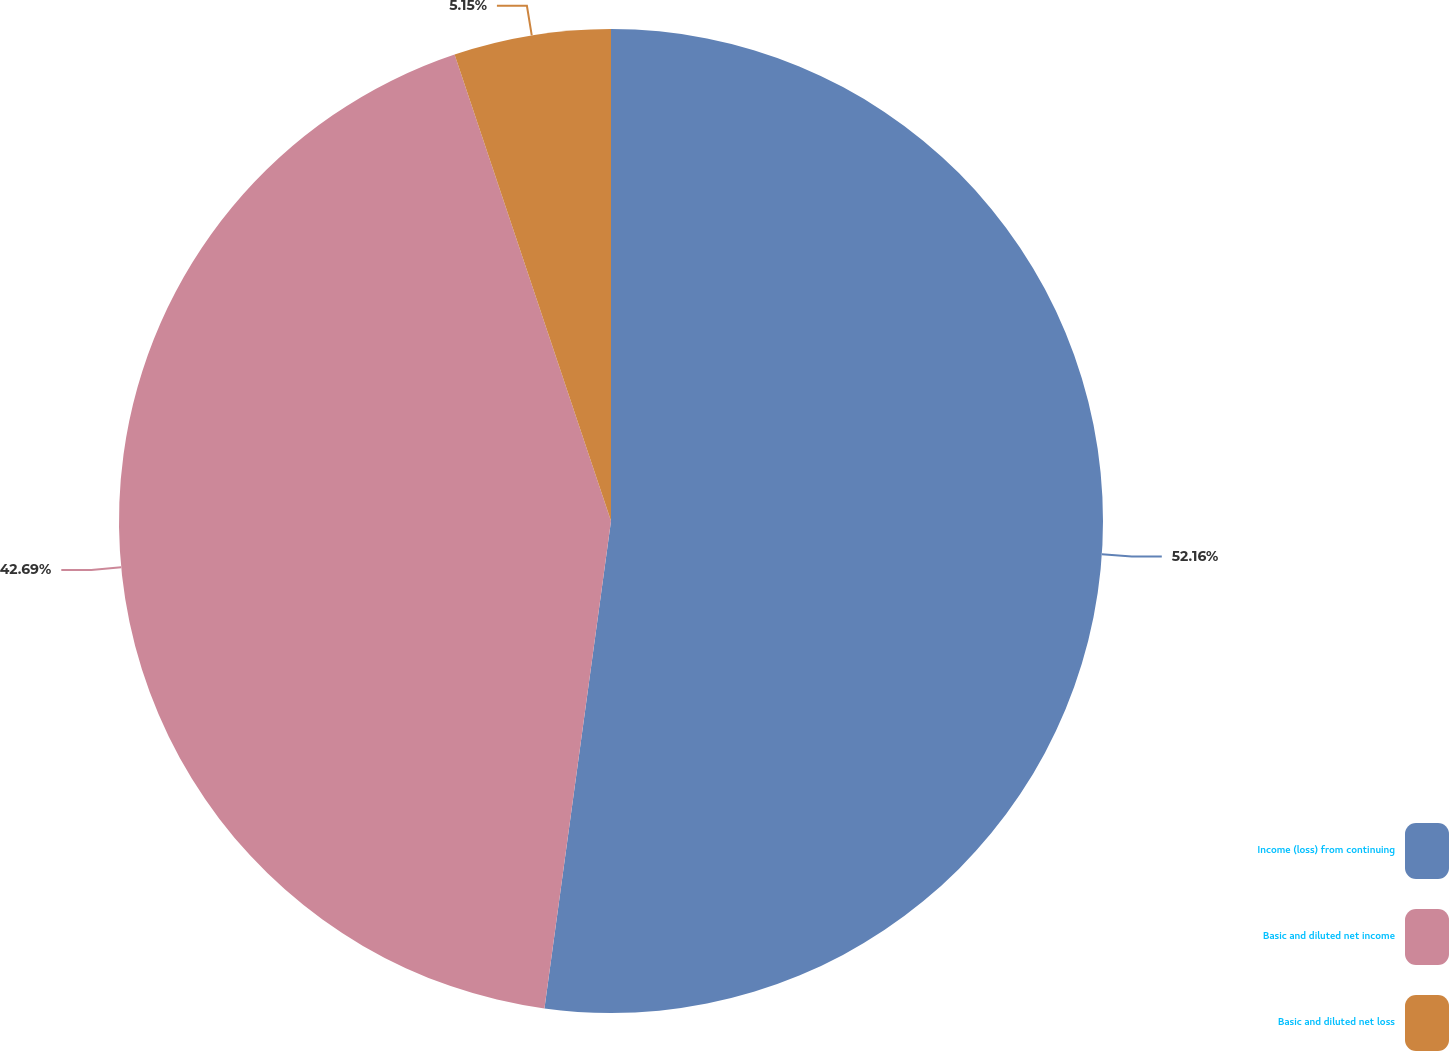Convert chart. <chart><loc_0><loc_0><loc_500><loc_500><pie_chart><fcel>Income (loss) from continuing<fcel>Basic and diluted net income<fcel>Basic and diluted net loss<nl><fcel>52.16%<fcel>42.69%<fcel>5.15%<nl></chart> 